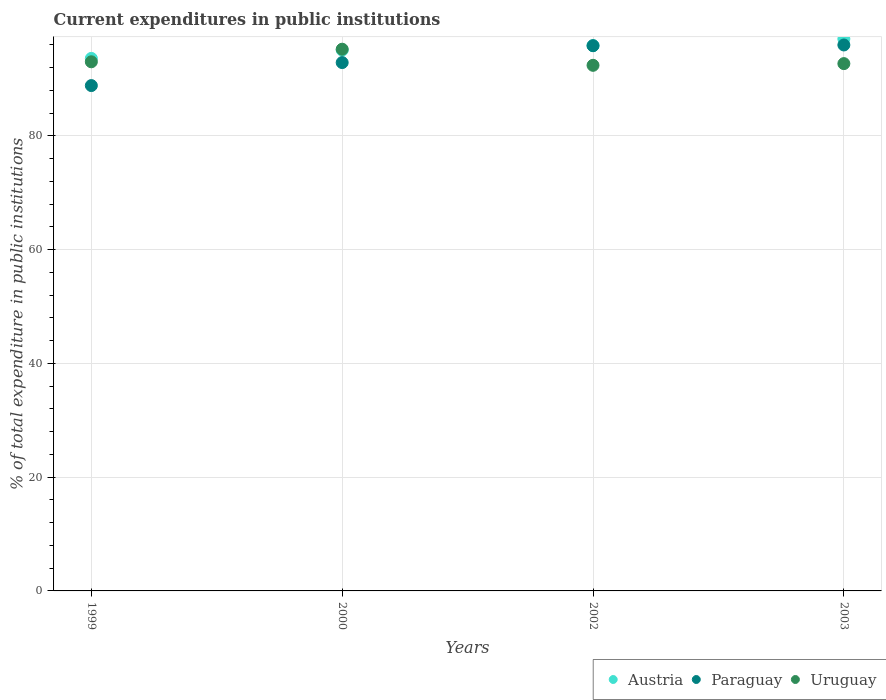What is the current expenditures in public institutions in Uruguay in 2002?
Provide a short and direct response. 92.42. Across all years, what is the maximum current expenditures in public institutions in Austria?
Offer a terse response. 97.07. Across all years, what is the minimum current expenditures in public institutions in Paraguay?
Give a very brief answer. 88.86. In which year was the current expenditures in public institutions in Paraguay maximum?
Provide a succinct answer. 2003. What is the total current expenditures in public institutions in Austria in the graph?
Offer a very short reply. 381.69. What is the difference between the current expenditures in public institutions in Uruguay in 1999 and that in 2000?
Offer a terse response. -2.21. What is the difference between the current expenditures in public institutions in Uruguay in 2002 and the current expenditures in public institutions in Paraguay in 2003?
Your answer should be compact. -3.58. What is the average current expenditures in public institutions in Uruguay per year?
Provide a succinct answer. 93.36. In the year 2003, what is the difference between the current expenditures in public institutions in Uruguay and current expenditures in public institutions in Austria?
Keep it short and to the point. -4.34. In how many years, is the current expenditures in public institutions in Austria greater than 32 %?
Make the answer very short. 4. What is the ratio of the current expenditures in public institutions in Paraguay in 2002 to that in 2003?
Your answer should be very brief. 1. Is the current expenditures in public institutions in Austria in 2000 less than that in 2003?
Your answer should be compact. Yes. What is the difference between the highest and the second highest current expenditures in public institutions in Uruguay?
Offer a very short reply. 2.21. What is the difference between the highest and the lowest current expenditures in public institutions in Paraguay?
Keep it short and to the point. 7.14. In how many years, is the current expenditures in public institutions in Paraguay greater than the average current expenditures in public institutions in Paraguay taken over all years?
Your answer should be very brief. 2. Is the sum of the current expenditures in public institutions in Austria in 1999 and 2003 greater than the maximum current expenditures in public institutions in Uruguay across all years?
Provide a short and direct response. Yes. How many years are there in the graph?
Offer a very short reply. 4. What is the difference between two consecutive major ticks on the Y-axis?
Your answer should be very brief. 20. Are the values on the major ticks of Y-axis written in scientific E-notation?
Offer a terse response. No. Where does the legend appear in the graph?
Your response must be concise. Bottom right. How many legend labels are there?
Give a very brief answer. 3. How are the legend labels stacked?
Make the answer very short. Horizontal. What is the title of the graph?
Your answer should be compact. Current expenditures in public institutions. What is the label or title of the X-axis?
Make the answer very short. Years. What is the label or title of the Y-axis?
Your answer should be very brief. % of total expenditure in public institutions. What is the % of total expenditure in public institutions of Austria in 1999?
Provide a succinct answer. 93.64. What is the % of total expenditure in public institutions of Paraguay in 1999?
Keep it short and to the point. 88.86. What is the % of total expenditure in public institutions of Uruguay in 1999?
Offer a terse response. 93.04. What is the % of total expenditure in public institutions in Austria in 2000?
Ensure brevity in your answer.  95.1. What is the % of total expenditure in public institutions in Paraguay in 2000?
Offer a very short reply. 92.9. What is the % of total expenditure in public institutions of Uruguay in 2000?
Your answer should be compact. 95.25. What is the % of total expenditure in public institutions in Austria in 2002?
Your answer should be compact. 95.88. What is the % of total expenditure in public institutions of Paraguay in 2002?
Make the answer very short. 95.88. What is the % of total expenditure in public institutions of Uruguay in 2002?
Give a very brief answer. 92.42. What is the % of total expenditure in public institutions in Austria in 2003?
Provide a succinct answer. 97.07. What is the % of total expenditure in public institutions in Paraguay in 2003?
Your answer should be compact. 96. What is the % of total expenditure in public institutions of Uruguay in 2003?
Make the answer very short. 92.72. Across all years, what is the maximum % of total expenditure in public institutions of Austria?
Provide a short and direct response. 97.07. Across all years, what is the maximum % of total expenditure in public institutions in Paraguay?
Keep it short and to the point. 96. Across all years, what is the maximum % of total expenditure in public institutions in Uruguay?
Ensure brevity in your answer.  95.25. Across all years, what is the minimum % of total expenditure in public institutions in Austria?
Your answer should be very brief. 93.64. Across all years, what is the minimum % of total expenditure in public institutions in Paraguay?
Make the answer very short. 88.86. Across all years, what is the minimum % of total expenditure in public institutions in Uruguay?
Make the answer very short. 92.42. What is the total % of total expenditure in public institutions in Austria in the graph?
Your answer should be very brief. 381.69. What is the total % of total expenditure in public institutions of Paraguay in the graph?
Your answer should be compact. 373.64. What is the total % of total expenditure in public institutions of Uruguay in the graph?
Make the answer very short. 373.44. What is the difference between the % of total expenditure in public institutions in Austria in 1999 and that in 2000?
Give a very brief answer. -1.47. What is the difference between the % of total expenditure in public institutions in Paraguay in 1999 and that in 2000?
Provide a succinct answer. -4.04. What is the difference between the % of total expenditure in public institutions in Uruguay in 1999 and that in 2000?
Your answer should be compact. -2.21. What is the difference between the % of total expenditure in public institutions in Austria in 1999 and that in 2002?
Provide a short and direct response. -2.24. What is the difference between the % of total expenditure in public institutions of Paraguay in 1999 and that in 2002?
Keep it short and to the point. -7.02. What is the difference between the % of total expenditure in public institutions of Uruguay in 1999 and that in 2002?
Make the answer very short. 0.62. What is the difference between the % of total expenditure in public institutions of Austria in 1999 and that in 2003?
Make the answer very short. -3.43. What is the difference between the % of total expenditure in public institutions in Paraguay in 1999 and that in 2003?
Ensure brevity in your answer.  -7.14. What is the difference between the % of total expenditure in public institutions in Uruguay in 1999 and that in 2003?
Your answer should be compact. 0.32. What is the difference between the % of total expenditure in public institutions of Austria in 2000 and that in 2002?
Your response must be concise. -0.77. What is the difference between the % of total expenditure in public institutions in Paraguay in 2000 and that in 2002?
Your answer should be very brief. -2.97. What is the difference between the % of total expenditure in public institutions of Uruguay in 2000 and that in 2002?
Offer a very short reply. 2.83. What is the difference between the % of total expenditure in public institutions in Austria in 2000 and that in 2003?
Your answer should be compact. -1.96. What is the difference between the % of total expenditure in public institutions in Paraguay in 2000 and that in 2003?
Offer a terse response. -3.1. What is the difference between the % of total expenditure in public institutions of Uruguay in 2000 and that in 2003?
Provide a short and direct response. 2.53. What is the difference between the % of total expenditure in public institutions in Austria in 2002 and that in 2003?
Your response must be concise. -1.19. What is the difference between the % of total expenditure in public institutions in Paraguay in 2002 and that in 2003?
Provide a succinct answer. -0.12. What is the difference between the % of total expenditure in public institutions of Uruguay in 2002 and that in 2003?
Your answer should be very brief. -0.3. What is the difference between the % of total expenditure in public institutions of Austria in 1999 and the % of total expenditure in public institutions of Paraguay in 2000?
Offer a very short reply. 0.73. What is the difference between the % of total expenditure in public institutions in Austria in 1999 and the % of total expenditure in public institutions in Uruguay in 2000?
Offer a very short reply. -1.62. What is the difference between the % of total expenditure in public institutions in Paraguay in 1999 and the % of total expenditure in public institutions in Uruguay in 2000?
Your answer should be compact. -6.39. What is the difference between the % of total expenditure in public institutions of Austria in 1999 and the % of total expenditure in public institutions of Paraguay in 2002?
Offer a very short reply. -2.24. What is the difference between the % of total expenditure in public institutions in Austria in 1999 and the % of total expenditure in public institutions in Uruguay in 2002?
Your response must be concise. 1.22. What is the difference between the % of total expenditure in public institutions in Paraguay in 1999 and the % of total expenditure in public institutions in Uruguay in 2002?
Keep it short and to the point. -3.56. What is the difference between the % of total expenditure in public institutions of Austria in 1999 and the % of total expenditure in public institutions of Paraguay in 2003?
Keep it short and to the point. -2.36. What is the difference between the % of total expenditure in public institutions in Austria in 1999 and the % of total expenditure in public institutions in Uruguay in 2003?
Offer a terse response. 0.92. What is the difference between the % of total expenditure in public institutions of Paraguay in 1999 and the % of total expenditure in public institutions of Uruguay in 2003?
Your answer should be compact. -3.86. What is the difference between the % of total expenditure in public institutions of Austria in 2000 and the % of total expenditure in public institutions of Paraguay in 2002?
Provide a short and direct response. -0.77. What is the difference between the % of total expenditure in public institutions in Austria in 2000 and the % of total expenditure in public institutions in Uruguay in 2002?
Your answer should be compact. 2.68. What is the difference between the % of total expenditure in public institutions in Paraguay in 2000 and the % of total expenditure in public institutions in Uruguay in 2002?
Ensure brevity in your answer.  0.48. What is the difference between the % of total expenditure in public institutions in Austria in 2000 and the % of total expenditure in public institutions in Paraguay in 2003?
Provide a short and direct response. -0.9. What is the difference between the % of total expenditure in public institutions in Austria in 2000 and the % of total expenditure in public institutions in Uruguay in 2003?
Your answer should be very brief. 2.38. What is the difference between the % of total expenditure in public institutions of Paraguay in 2000 and the % of total expenditure in public institutions of Uruguay in 2003?
Provide a succinct answer. 0.18. What is the difference between the % of total expenditure in public institutions of Austria in 2002 and the % of total expenditure in public institutions of Paraguay in 2003?
Offer a terse response. -0.12. What is the difference between the % of total expenditure in public institutions in Austria in 2002 and the % of total expenditure in public institutions in Uruguay in 2003?
Your answer should be compact. 3.16. What is the difference between the % of total expenditure in public institutions of Paraguay in 2002 and the % of total expenditure in public institutions of Uruguay in 2003?
Your answer should be compact. 3.15. What is the average % of total expenditure in public institutions in Austria per year?
Provide a short and direct response. 95.42. What is the average % of total expenditure in public institutions of Paraguay per year?
Your answer should be compact. 93.41. What is the average % of total expenditure in public institutions in Uruguay per year?
Your answer should be compact. 93.36. In the year 1999, what is the difference between the % of total expenditure in public institutions in Austria and % of total expenditure in public institutions in Paraguay?
Offer a terse response. 4.78. In the year 1999, what is the difference between the % of total expenditure in public institutions in Austria and % of total expenditure in public institutions in Uruguay?
Ensure brevity in your answer.  0.6. In the year 1999, what is the difference between the % of total expenditure in public institutions of Paraguay and % of total expenditure in public institutions of Uruguay?
Your answer should be compact. -4.18. In the year 2000, what is the difference between the % of total expenditure in public institutions in Austria and % of total expenditure in public institutions in Paraguay?
Provide a succinct answer. 2.2. In the year 2000, what is the difference between the % of total expenditure in public institutions of Austria and % of total expenditure in public institutions of Uruguay?
Keep it short and to the point. -0.15. In the year 2000, what is the difference between the % of total expenditure in public institutions of Paraguay and % of total expenditure in public institutions of Uruguay?
Your answer should be compact. -2.35. In the year 2002, what is the difference between the % of total expenditure in public institutions of Austria and % of total expenditure in public institutions of Paraguay?
Your answer should be compact. 0. In the year 2002, what is the difference between the % of total expenditure in public institutions in Austria and % of total expenditure in public institutions in Uruguay?
Ensure brevity in your answer.  3.46. In the year 2002, what is the difference between the % of total expenditure in public institutions of Paraguay and % of total expenditure in public institutions of Uruguay?
Your answer should be very brief. 3.45. In the year 2003, what is the difference between the % of total expenditure in public institutions in Austria and % of total expenditure in public institutions in Paraguay?
Offer a terse response. 1.07. In the year 2003, what is the difference between the % of total expenditure in public institutions of Austria and % of total expenditure in public institutions of Uruguay?
Give a very brief answer. 4.34. In the year 2003, what is the difference between the % of total expenditure in public institutions of Paraguay and % of total expenditure in public institutions of Uruguay?
Keep it short and to the point. 3.28. What is the ratio of the % of total expenditure in public institutions in Austria in 1999 to that in 2000?
Make the answer very short. 0.98. What is the ratio of the % of total expenditure in public institutions in Paraguay in 1999 to that in 2000?
Provide a short and direct response. 0.96. What is the ratio of the % of total expenditure in public institutions in Uruguay in 1999 to that in 2000?
Offer a terse response. 0.98. What is the ratio of the % of total expenditure in public institutions in Austria in 1999 to that in 2002?
Provide a succinct answer. 0.98. What is the ratio of the % of total expenditure in public institutions in Paraguay in 1999 to that in 2002?
Provide a short and direct response. 0.93. What is the ratio of the % of total expenditure in public institutions in Austria in 1999 to that in 2003?
Provide a short and direct response. 0.96. What is the ratio of the % of total expenditure in public institutions of Paraguay in 1999 to that in 2003?
Your answer should be very brief. 0.93. What is the ratio of the % of total expenditure in public institutions in Paraguay in 2000 to that in 2002?
Your answer should be compact. 0.97. What is the ratio of the % of total expenditure in public institutions of Uruguay in 2000 to that in 2002?
Provide a short and direct response. 1.03. What is the ratio of the % of total expenditure in public institutions of Austria in 2000 to that in 2003?
Provide a succinct answer. 0.98. What is the ratio of the % of total expenditure in public institutions of Paraguay in 2000 to that in 2003?
Ensure brevity in your answer.  0.97. What is the ratio of the % of total expenditure in public institutions in Uruguay in 2000 to that in 2003?
Your response must be concise. 1.03. What is the difference between the highest and the second highest % of total expenditure in public institutions of Austria?
Ensure brevity in your answer.  1.19. What is the difference between the highest and the second highest % of total expenditure in public institutions of Paraguay?
Your response must be concise. 0.12. What is the difference between the highest and the second highest % of total expenditure in public institutions of Uruguay?
Keep it short and to the point. 2.21. What is the difference between the highest and the lowest % of total expenditure in public institutions of Austria?
Give a very brief answer. 3.43. What is the difference between the highest and the lowest % of total expenditure in public institutions of Paraguay?
Ensure brevity in your answer.  7.14. What is the difference between the highest and the lowest % of total expenditure in public institutions of Uruguay?
Make the answer very short. 2.83. 